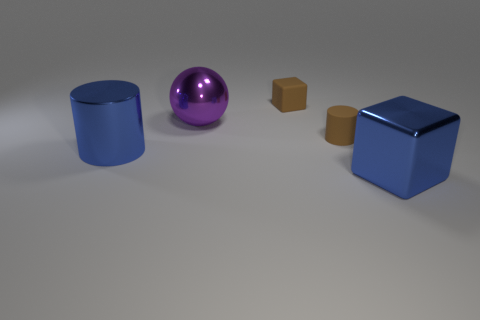Is the number of tiny brown things on the left side of the brown block the same as the number of large purple spheres that are left of the large cylinder?
Keep it short and to the point. Yes. What material is the large purple object that is to the left of the big blue metal thing in front of the shiny cylinder?
Offer a terse response. Metal. How many objects are large things or things that are right of the large shiny cylinder?
Your answer should be compact. 5. There is a purple ball that is made of the same material as the large blue cube; what is its size?
Your answer should be very brief. Large. Is the number of small brown matte objects behind the small rubber cube greater than the number of metal balls?
Offer a terse response. No. How big is the thing that is behind the small rubber cylinder and in front of the brown rubber cube?
Keep it short and to the point. Large. Is the size of the rubber object that is left of the rubber cylinder the same as the purple shiny object?
Provide a short and direct response. No. What color is the object that is both right of the ball and to the left of the brown matte cylinder?
Ensure brevity in your answer.  Brown. What number of brown cylinders are behind the block that is on the left side of the small cylinder?
Keep it short and to the point. 0. Are there any other things that have the same color as the matte block?
Your answer should be compact. Yes. 